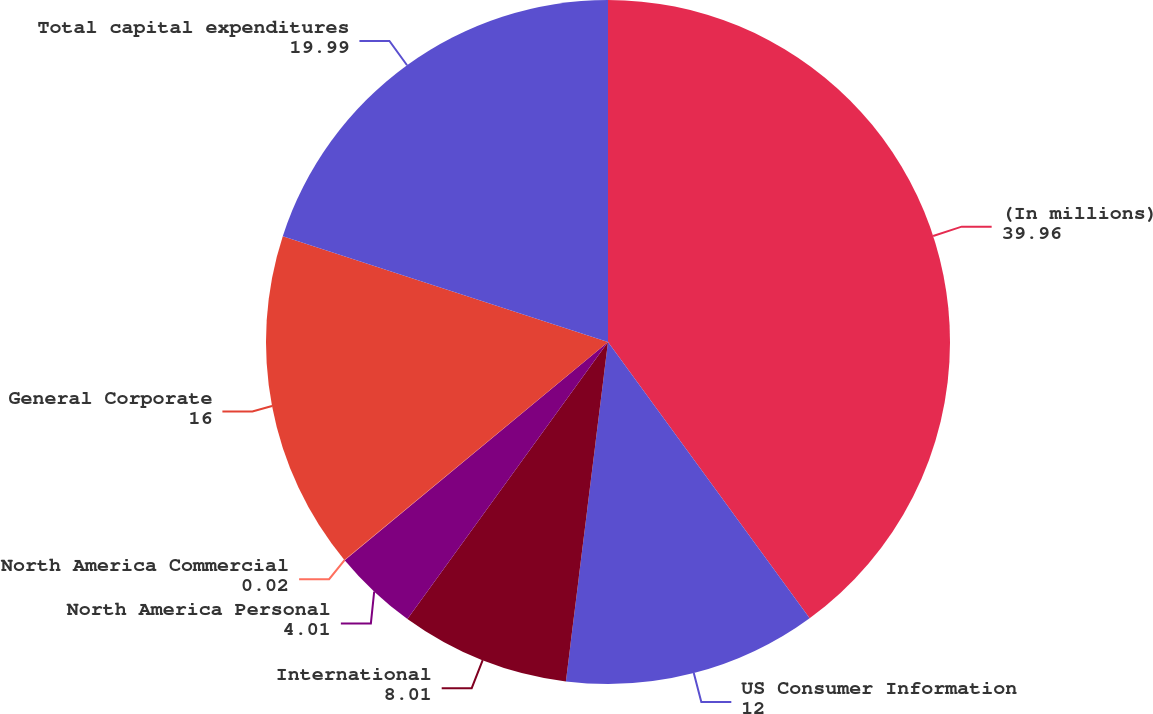<chart> <loc_0><loc_0><loc_500><loc_500><pie_chart><fcel>(In millions)<fcel>US Consumer Information<fcel>International<fcel>North America Personal<fcel>North America Commercial<fcel>General Corporate<fcel>Total capital expenditures<nl><fcel>39.96%<fcel>12.0%<fcel>8.01%<fcel>4.01%<fcel>0.02%<fcel>16.0%<fcel>19.99%<nl></chart> 